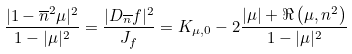<formula> <loc_0><loc_0><loc_500><loc_500>\frac { | 1 - \overline { n } ^ { 2 } \mu | ^ { 2 } } { 1 - | \mu | ^ { 2 } } = \frac { | D _ { \overline { n } } f | ^ { 2 } } { J _ { f } } = K _ { \mu , 0 } - 2 \frac { | \mu | + \Re \left ( \mu , n ^ { 2 } \right ) } { 1 - | \mu | ^ { 2 } }</formula> 